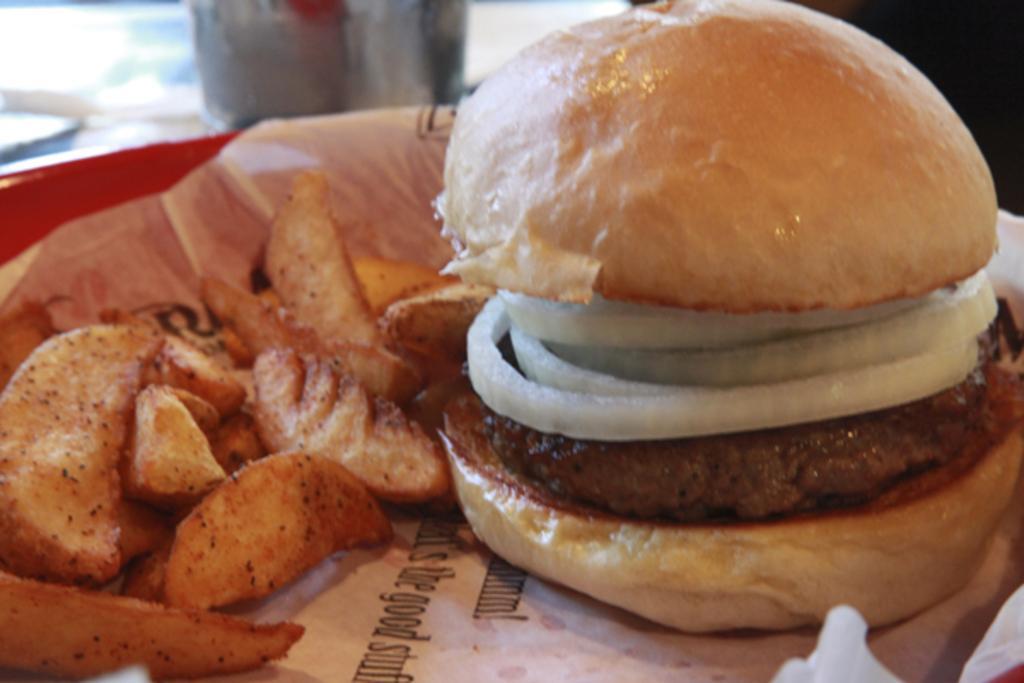Describe this image in one or two sentences. There is a plate. On that there is a paper. Also there is a burger with onion pieces and patty. Also there are some potato fries. 